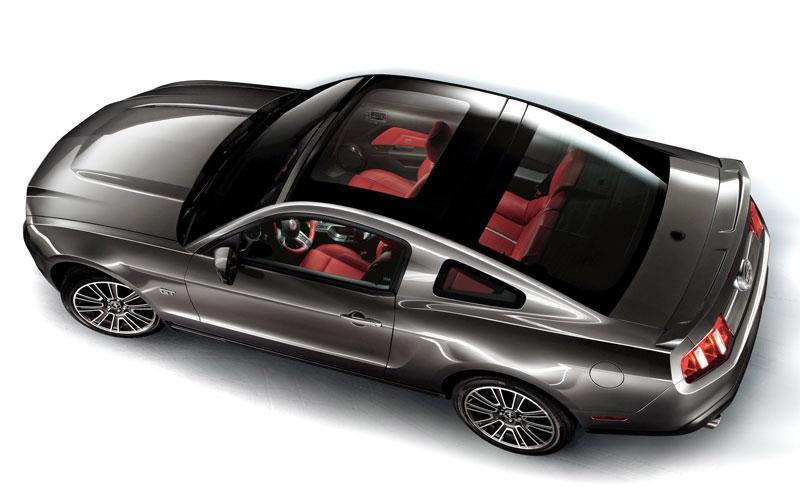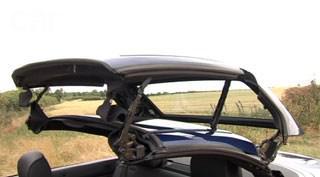The first image is the image on the left, the second image is the image on the right. Examine the images to the left and right. Is the description "there is a man standing next to a car in one of the images." accurate? Answer yes or no. No. The first image is the image on the left, the second image is the image on the right. For the images shown, is this caption "both pictures have convertibles in them" true? Answer yes or no. No. 